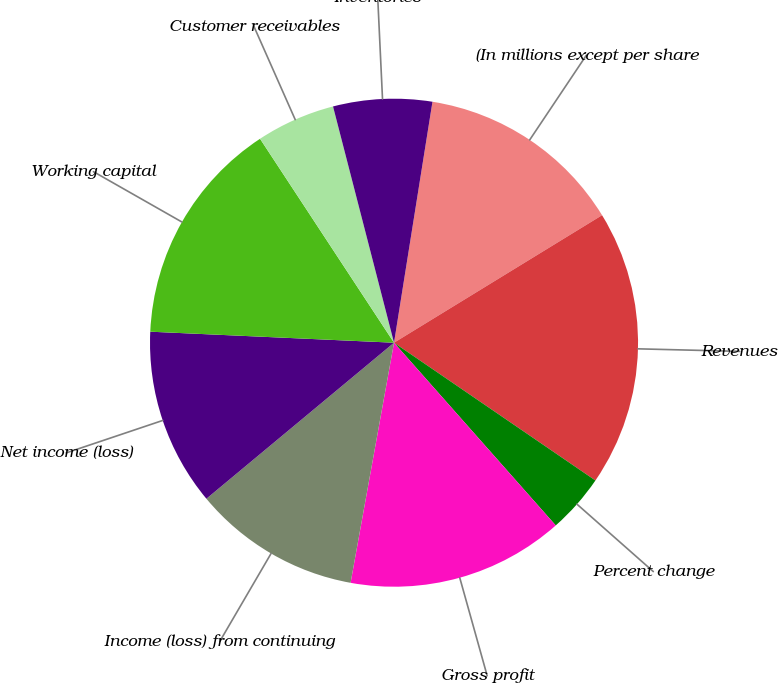Convert chart to OTSL. <chart><loc_0><loc_0><loc_500><loc_500><pie_chart><fcel>(In millions except per share<fcel>Revenues<fcel>Percent change<fcel>Gross profit<fcel>Income (loss) from continuing<fcel>Net income (loss)<fcel>Working capital<fcel>Customer receivables<fcel>Inventories<nl><fcel>13.73%<fcel>18.3%<fcel>3.92%<fcel>14.38%<fcel>11.11%<fcel>11.76%<fcel>15.03%<fcel>5.23%<fcel>6.54%<nl></chart> 